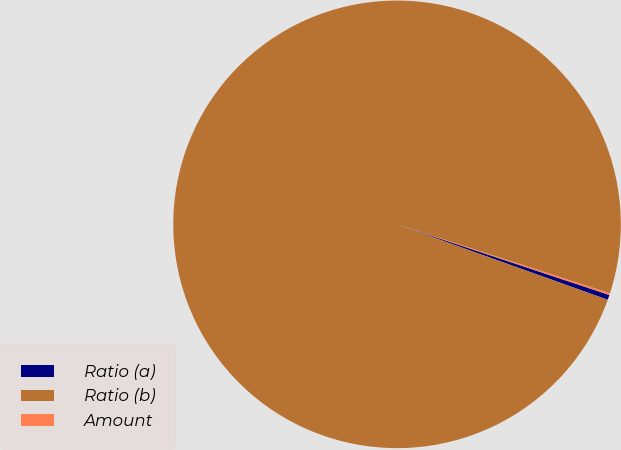Convert chart to OTSL. <chart><loc_0><loc_0><loc_500><loc_500><pie_chart><fcel>Ratio (a)<fcel>Ratio (b)<fcel>Amount<nl><fcel>0.36%<fcel>99.52%<fcel>0.13%<nl></chart> 